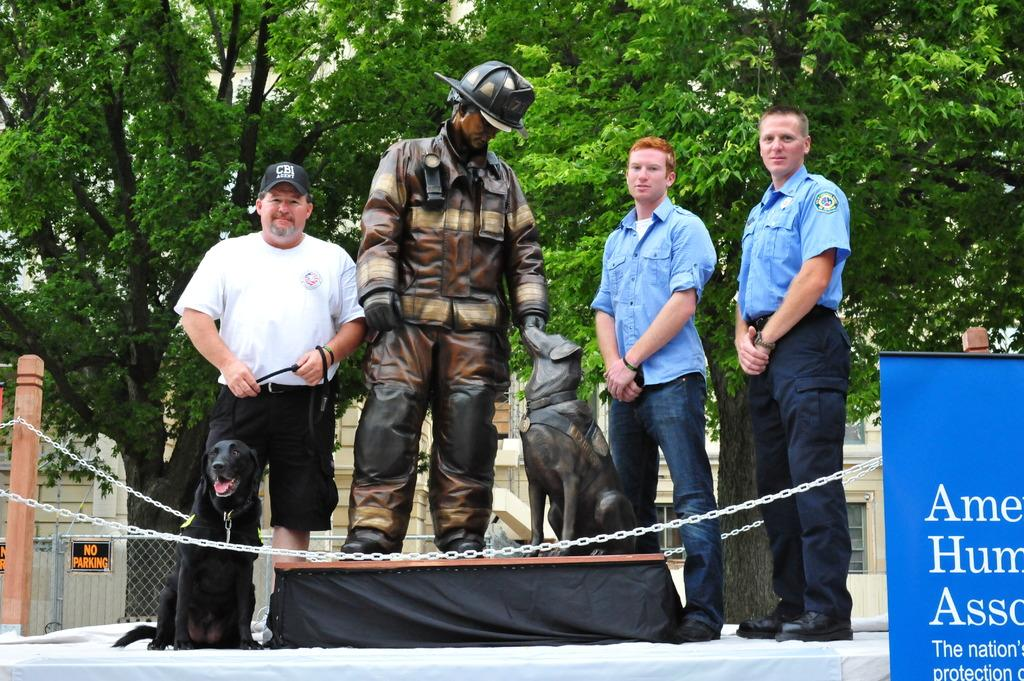How many people are present in the image? There are three persons standing in the image. What can be seen besides the people in the image? There is a statue of a person and a dog in the image. What is visible in the background of the image? Trees, a sign board, and the sky are visible in the background of the image. What type of cart is being used by the actor in the image? There is no actor or cart present in the image. Can you describe the twig that the person is holding in the image? There is no twig visible in the image; the people are not holding any objects. 